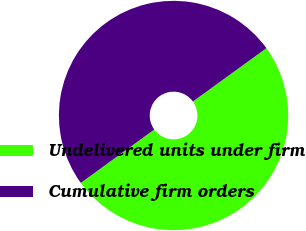<chart> <loc_0><loc_0><loc_500><loc_500><pie_chart><fcel>Undelivered units under firm<fcel>Cumulative firm orders<nl><fcel>49.99%<fcel>50.01%<nl></chart> 